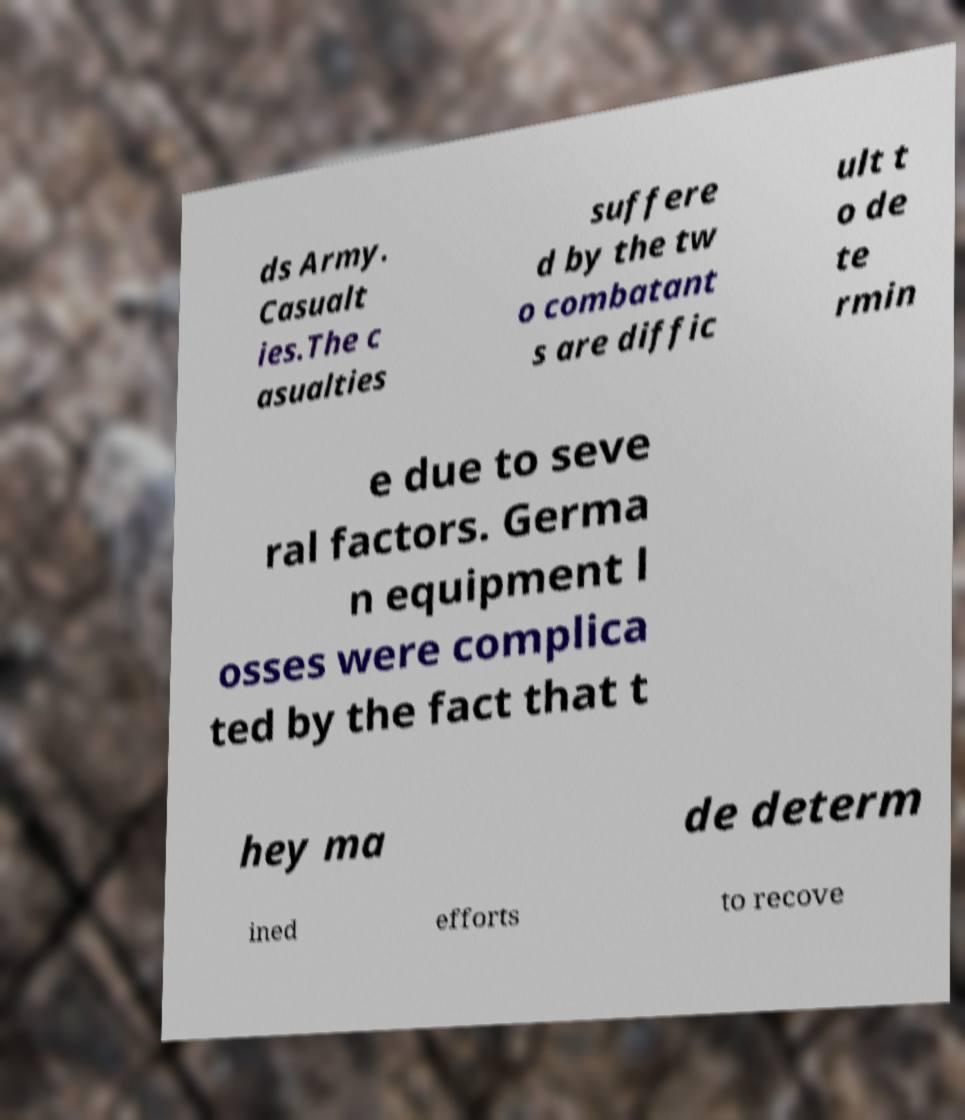Could you assist in decoding the text presented in this image and type it out clearly? ds Army. Casualt ies.The c asualties suffere d by the tw o combatant s are diffic ult t o de te rmin e due to seve ral factors. Germa n equipment l osses were complica ted by the fact that t hey ma de determ ined efforts to recove 